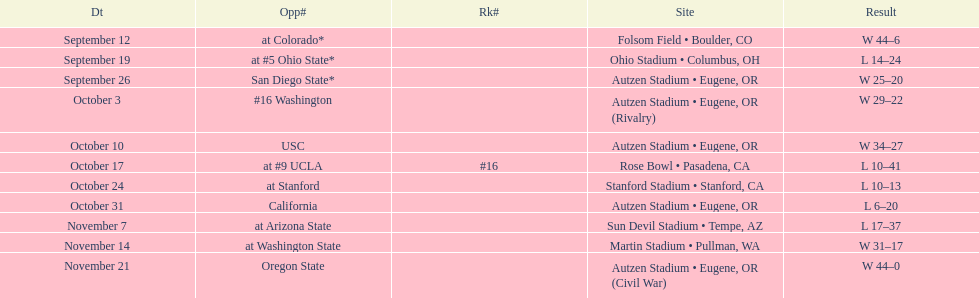How many wins are listed for the season? 6. 